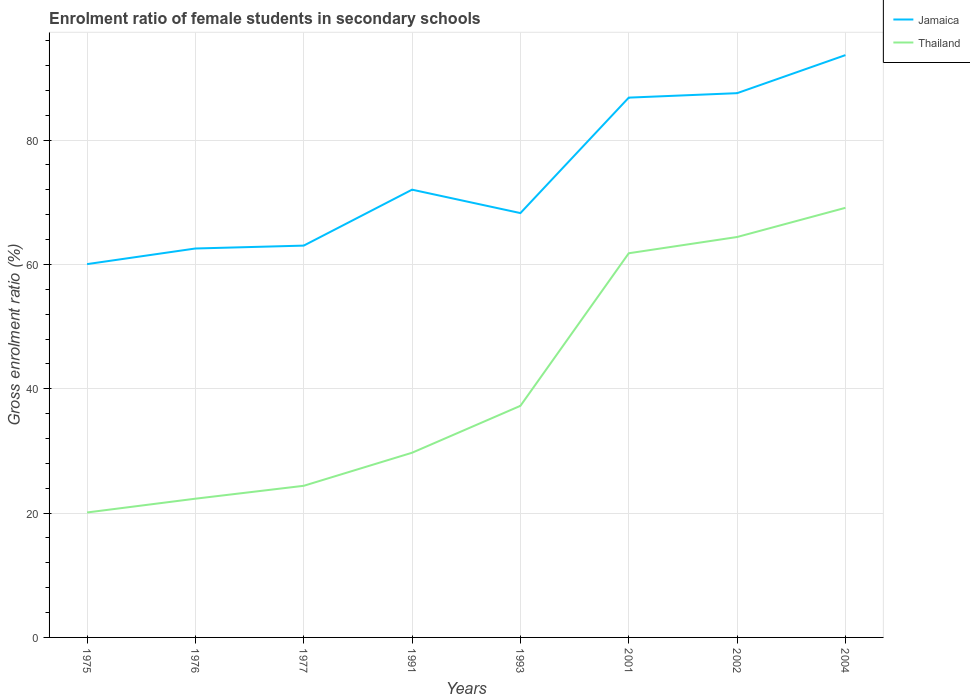How many different coloured lines are there?
Ensure brevity in your answer.  2. Does the line corresponding to Jamaica intersect with the line corresponding to Thailand?
Give a very brief answer. No. Across all years, what is the maximum enrolment ratio of female students in secondary schools in Thailand?
Offer a terse response. 20.1. In which year was the enrolment ratio of female students in secondary schools in Thailand maximum?
Keep it short and to the point. 1975. What is the total enrolment ratio of female students in secondary schools in Thailand in the graph?
Give a very brief answer. -44.71. What is the difference between the highest and the second highest enrolment ratio of female students in secondary schools in Jamaica?
Offer a terse response. 33.62. How many lines are there?
Make the answer very short. 2. How many years are there in the graph?
Offer a terse response. 8. What is the difference between two consecutive major ticks on the Y-axis?
Your answer should be very brief. 20. Does the graph contain any zero values?
Provide a short and direct response. No. Does the graph contain grids?
Give a very brief answer. Yes. How many legend labels are there?
Provide a succinct answer. 2. What is the title of the graph?
Offer a terse response. Enrolment ratio of female students in secondary schools. Does "Antigua and Barbuda" appear as one of the legend labels in the graph?
Ensure brevity in your answer.  No. What is the label or title of the X-axis?
Give a very brief answer. Years. What is the label or title of the Y-axis?
Your response must be concise. Gross enrolment ratio (%). What is the Gross enrolment ratio (%) in Jamaica in 1975?
Keep it short and to the point. 60.05. What is the Gross enrolment ratio (%) in Thailand in 1975?
Make the answer very short. 20.1. What is the Gross enrolment ratio (%) in Jamaica in 1976?
Make the answer very short. 62.56. What is the Gross enrolment ratio (%) in Thailand in 1976?
Keep it short and to the point. 22.32. What is the Gross enrolment ratio (%) in Jamaica in 1977?
Keep it short and to the point. 63.03. What is the Gross enrolment ratio (%) in Thailand in 1977?
Give a very brief answer. 24.39. What is the Gross enrolment ratio (%) in Jamaica in 1991?
Provide a succinct answer. 72.02. What is the Gross enrolment ratio (%) in Thailand in 1991?
Offer a very short reply. 29.71. What is the Gross enrolment ratio (%) of Jamaica in 1993?
Your response must be concise. 68.26. What is the Gross enrolment ratio (%) of Thailand in 1993?
Your response must be concise. 37.25. What is the Gross enrolment ratio (%) in Jamaica in 2001?
Your answer should be very brief. 86.83. What is the Gross enrolment ratio (%) of Thailand in 2001?
Keep it short and to the point. 61.8. What is the Gross enrolment ratio (%) of Jamaica in 2002?
Provide a succinct answer. 87.54. What is the Gross enrolment ratio (%) in Thailand in 2002?
Offer a terse response. 64.41. What is the Gross enrolment ratio (%) of Jamaica in 2004?
Ensure brevity in your answer.  93.67. What is the Gross enrolment ratio (%) of Thailand in 2004?
Your answer should be compact. 69.1. Across all years, what is the maximum Gross enrolment ratio (%) of Jamaica?
Provide a succinct answer. 93.67. Across all years, what is the maximum Gross enrolment ratio (%) in Thailand?
Your answer should be compact. 69.1. Across all years, what is the minimum Gross enrolment ratio (%) of Jamaica?
Your response must be concise. 60.05. Across all years, what is the minimum Gross enrolment ratio (%) in Thailand?
Your answer should be compact. 20.1. What is the total Gross enrolment ratio (%) of Jamaica in the graph?
Offer a very short reply. 593.95. What is the total Gross enrolment ratio (%) in Thailand in the graph?
Your response must be concise. 329.07. What is the difference between the Gross enrolment ratio (%) in Jamaica in 1975 and that in 1976?
Your answer should be very brief. -2.51. What is the difference between the Gross enrolment ratio (%) of Thailand in 1975 and that in 1976?
Offer a very short reply. -2.22. What is the difference between the Gross enrolment ratio (%) in Jamaica in 1975 and that in 1977?
Ensure brevity in your answer.  -2.98. What is the difference between the Gross enrolment ratio (%) of Thailand in 1975 and that in 1977?
Your answer should be compact. -4.29. What is the difference between the Gross enrolment ratio (%) in Jamaica in 1975 and that in 1991?
Provide a short and direct response. -11.98. What is the difference between the Gross enrolment ratio (%) of Thailand in 1975 and that in 1991?
Your answer should be compact. -9.61. What is the difference between the Gross enrolment ratio (%) of Jamaica in 1975 and that in 1993?
Keep it short and to the point. -8.21. What is the difference between the Gross enrolment ratio (%) in Thailand in 1975 and that in 1993?
Provide a short and direct response. -17.16. What is the difference between the Gross enrolment ratio (%) in Jamaica in 1975 and that in 2001?
Provide a short and direct response. -26.78. What is the difference between the Gross enrolment ratio (%) of Thailand in 1975 and that in 2001?
Provide a short and direct response. -41.7. What is the difference between the Gross enrolment ratio (%) in Jamaica in 1975 and that in 2002?
Offer a terse response. -27.5. What is the difference between the Gross enrolment ratio (%) of Thailand in 1975 and that in 2002?
Offer a very short reply. -44.31. What is the difference between the Gross enrolment ratio (%) of Jamaica in 1975 and that in 2004?
Offer a terse response. -33.62. What is the difference between the Gross enrolment ratio (%) of Thailand in 1975 and that in 2004?
Provide a short and direct response. -49.01. What is the difference between the Gross enrolment ratio (%) in Jamaica in 1976 and that in 1977?
Provide a short and direct response. -0.47. What is the difference between the Gross enrolment ratio (%) of Thailand in 1976 and that in 1977?
Make the answer very short. -2.07. What is the difference between the Gross enrolment ratio (%) in Jamaica in 1976 and that in 1991?
Make the answer very short. -9.46. What is the difference between the Gross enrolment ratio (%) of Thailand in 1976 and that in 1991?
Offer a very short reply. -7.39. What is the difference between the Gross enrolment ratio (%) in Jamaica in 1976 and that in 1993?
Give a very brief answer. -5.7. What is the difference between the Gross enrolment ratio (%) of Thailand in 1976 and that in 1993?
Provide a succinct answer. -14.94. What is the difference between the Gross enrolment ratio (%) of Jamaica in 1976 and that in 2001?
Your answer should be very brief. -24.27. What is the difference between the Gross enrolment ratio (%) in Thailand in 1976 and that in 2001?
Offer a terse response. -39.48. What is the difference between the Gross enrolment ratio (%) of Jamaica in 1976 and that in 2002?
Keep it short and to the point. -24.98. What is the difference between the Gross enrolment ratio (%) of Thailand in 1976 and that in 2002?
Give a very brief answer. -42.09. What is the difference between the Gross enrolment ratio (%) in Jamaica in 1976 and that in 2004?
Make the answer very short. -31.11. What is the difference between the Gross enrolment ratio (%) of Thailand in 1976 and that in 2004?
Your answer should be very brief. -46.79. What is the difference between the Gross enrolment ratio (%) of Jamaica in 1977 and that in 1991?
Provide a succinct answer. -9. What is the difference between the Gross enrolment ratio (%) of Thailand in 1977 and that in 1991?
Ensure brevity in your answer.  -5.32. What is the difference between the Gross enrolment ratio (%) of Jamaica in 1977 and that in 1993?
Make the answer very short. -5.23. What is the difference between the Gross enrolment ratio (%) in Thailand in 1977 and that in 1993?
Give a very brief answer. -12.86. What is the difference between the Gross enrolment ratio (%) of Jamaica in 1977 and that in 2001?
Your answer should be very brief. -23.8. What is the difference between the Gross enrolment ratio (%) of Thailand in 1977 and that in 2001?
Provide a short and direct response. -37.41. What is the difference between the Gross enrolment ratio (%) in Jamaica in 1977 and that in 2002?
Your response must be concise. -24.52. What is the difference between the Gross enrolment ratio (%) of Thailand in 1977 and that in 2002?
Ensure brevity in your answer.  -40.02. What is the difference between the Gross enrolment ratio (%) in Jamaica in 1977 and that in 2004?
Provide a succinct answer. -30.64. What is the difference between the Gross enrolment ratio (%) in Thailand in 1977 and that in 2004?
Keep it short and to the point. -44.71. What is the difference between the Gross enrolment ratio (%) in Jamaica in 1991 and that in 1993?
Provide a succinct answer. 3.77. What is the difference between the Gross enrolment ratio (%) in Thailand in 1991 and that in 1993?
Provide a short and direct response. -7.55. What is the difference between the Gross enrolment ratio (%) in Jamaica in 1991 and that in 2001?
Provide a short and direct response. -14.8. What is the difference between the Gross enrolment ratio (%) of Thailand in 1991 and that in 2001?
Ensure brevity in your answer.  -32.09. What is the difference between the Gross enrolment ratio (%) in Jamaica in 1991 and that in 2002?
Make the answer very short. -15.52. What is the difference between the Gross enrolment ratio (%) of Thailand in 1991 and that in 2002?
Your response must be concise. -34.7. What is the difference between the Gross enrolment ratio (%) in Jamaica in 1991 and that in 2004?
Your answer should be compact. -21.64. What is the difference between the Gross enrolment ratio (%) in Thailand in 1991 and that in 2004?
Provide a short and direct response. -39.4. What is the difference between the Gross enrolment ratio (%) in Jamaica in 1993 and that in 2001?
Offer a terse response. -18.57. What is the difference between the Gross enrolment ratio (%) of Thailand in 1993 and that in 2001?
Offer a very short reply. -24.54. What is the difference between the Gross enrolment ratio (%) in Jamaica in 1993 and that in 2002?
Your response must be concise. -19.29. What is the difference between the Gross enrolment ratio (%) in Thailand in 1993 and that in 2002?
Provide a short and direct response. -27.15. What is the difference between the Gross enrolment ratio (%) in Jamaica in 1993 and that in 2004?
Ensure brevity in your answer.  -25.41. What is the difference between the Gross enrolment ratio (%) of Thailand in 1993 and that in 2004?
Make the answer very short. -31.85. What is the difference between the Gross enrolment ratio (%) of Jamaica in 2001 and that in 2002?
Make the answer very short. -0.72. What is the difference between the Gross enrolment ratio (%) of Thailand in 2001 and that in 2002?
Provide a succinct answer. -2.61. What is the difference between the Gross enrolment ratio (%) in Jamaica in 2001 and that in 2004?
Provide a short and direct response. -6.84. What is the difference between the Gross enrolment ratio (%) in Thailand in 2001 and that in 2004?
Your answer should be compact. -7.31. What is the difference between the Gross enrolment ratio (%) of Jamaica in 2002 and that in 2004?
Your answer should be compact. -6.12. What is the difference between the Gross enrolment ratio (%) of Thailand in 2002 and that in 2004?
Your answer should be compact. -4.7. What is the difference between the Gross enrolment ratio (%) in Jamaica in 1975 and the Gross enrolment ratio (%) in Thailand in 1976?
Offer a terse response. 37.73. What is the difference between the Gross enrolment ratio (%) of Jamaica in 1975 and the Gross enrolment ratio (%) of Thailand in 1977?
Provide a succinct answer. 35.66. What is the difference between the Gross enrolment ratio (%) in Jamaica in 1975 and the Gross enrolment ratio (%) in Thailand in 1991?
Make the answer very short. 30.34. What is the difference between the Gross enrolment ratio (%) in Jamaica in 1975 and the Gross enrolment ratio (%) in Thailand in 1993?
Make the answer very short. 22.79. What is the difference between the Gross enrolment ratio (%) of Jamaica in 1975 and the Gross enrolment ratio (%) of Thailand in 2001?
Your response must be concise. -1.75. What is the difference between the Gross enrolment ratio (%) of Jamaica in 1975 and the Gross enrolment ratio (%) of Thailand in 2002?
Keep it short and to the point. -4.36. What is the difference between the Gross enrolment ratio (%) of Jamaica in 1975 and the Gross enrolment ratio (%) of Thailand in 2004?
Your answer should be compact. -9.06. What is the difference between the Gross enrolment ratio (%) of Jamaica in 1976 and the Gross enrolment ratio (%) of Thailand in 1977?
Offer a very short reply. 38.17. What is the difference between the Gross enrolment ratio (%) in Jamaica in 1976 and the Gross enrolment ratio (%) in Thailand in 1991?
Provide a short and direct response. 32.85. What is the difference between the Gross enrolment ratio (%) in Jamaica in 1976 and the Gross enrolment ratio (%) in Thailand in 1993?
Offer a terse response. 25.31. What is the difference between the Gross enrolment ratio (%) in Jamaica in 1976 and the Gross enrolment ratio (%) in Thailand in 2001?
Provide a succinct answer. 0.76. What is the difference between the Gross enrolment ratio (%) of Jamaica in 1976 and the Gross enrolment ratio (%) of Thailand in 2002?
Your answer should be very brief. -1.85. What is the difference between the Gross enrolment ratio (%) in Jamaica in 1976 and the Gross enrolment ratio (%) in Thailand in 2004?
Your answer should be compact. -6.54. What is the difference between the Gross enrolment ratio (%) in Jamaica in 1977 and the Gross enrolment ratio (%) in Thailand in 1991?
Your response must be concise. 33.32. What is the difference between the Gross enrolment ratio (%) in Jamaica in 1977 and the Gross enrolment ratio (%) in Thailand in 1993?
Offer a very short reply. 25.77. What is the difference between the Gross enrolment ratio (%) of Jamaica in 1977 and the Gross enrolment ratio (%) of Thailand in 2001?
Provide a short and direct response. 1.23. What is the difference between the Gross enrolment ratio (%) of Jamaica in 1977 and the Gross enrolment ratio (%) of Thailand in 2002?
Provide a short and direct response. -1.38. What is the difference between the Gross enrolment ratio (%) in Jamaica in 1977 and the Gross enrolment ratio (%) in Thailand in 2004?
Keep it short and to the point. -6.08. What is the difference between the Gross enrolment ratio (%) of Jamaica in 1991 and the Gross enrolment ratio (%) of Thailand in 1993?
Offer a terse response. 34.77. What is the difference between the Gross enrolment ratio (%) in Jamaica in 1991 and the Gross enrolment ratio (%) in Thailand in 2001?
Keep it short and to the point. 10.23. What is the difference between the Gross enrolment ratio (%) in Jamaica in 1991 and the Gross enrolment ratio (%) in Thailand in 2002?
Your answer should be compact. 7.61. What is the difference between the Gross enrolment ratio (%) in Jamaica in 1991 and the Gross enrolment ratio (%) in Thailand in 2004?
Make the answer very short. 2.92. What is the difference between the Gross enrolment ratio (%) of Jamaica in 1993 and the Gross enrolment ratio (%) of Thailand in 2001?
Offer a terse response. 6.46. What is the difference between the Gross enrolment ratio (%) of Jamaica in 1993 and the Gross enrolment ratio (%) of Thailand in 2002?
Offer a very short reply. 3.85. What is the difference between the Gross enrolment ratio (%) of Jamaica in 1993 and the Gross enrolment ratio (%) of Thailand in 2004?
Your answer should be very brief. -0.85. What is the difference between the Gross enrolment ratio (%) of Jamaica in 2001 and the Gross enrolment ratio (%) of Thailand in 2002?
Provide a short and direct response. 22.42. What is the difference between the Gross enrolment ratio (%) in Jamaica in 2001 and the Gross enrolment ratio (%) in Thailand in 2004?
Provide a succinct answer. 17.72. What is the difference between the Gross enrolment ratio (%) in Jamaica in 2002 and the Gross enrolment ratio (%) in Thailand in 2004?
Make the answer very short. 18.44. What is the average Gross enrolment ratio (%) in Jamaica per year?
Your response must be concise. 74.24. What is the average Gross enrolment ratio (%) in Thailand per year?
Your answer should be compact. 41.13. In the year 1975, what is the difference between the Gross enrolment ratio (%) of Jamaica and Gross enrolment ratio (%) of Thailand?
Provide a short and direct response. 39.95. In the year 1976, what is the difference between the Gross enrolment ratio (%) of Jamaica and Gross enrolment ratio (%) of Thailand?
Offer a very short reply. 40.24. In the year 1977, what is the difference between the Gross enrolment ratio (%) of Jamaica and Gross enrolment ratio (%) of Thailand?
Offer a very short reply. 38.64. In the year 1991, what is the difference between the Gross enrolment ratio (%) of Jamaica and Gross enrolment ratio (%) of Thailand?
Ensure brevity in your answer.  42.31. In the year 1993, what is the difference between the Gross enrolment ratio (%) in Jamaica and Gross enrolment ratio (%) in Thailand?
Keep it short and to the point. 31. In the year 2001, what is the difference between the Gross enrolment ratio (%) in Jamaica and Gross enrolment ratio (%) in Thailand?
Provide a short and direct response. 25.03. In the year 2002, what is the difference between the Gross enrolment ratio (%) in Jamaica and Gross enrolment ratio (%) in Thailand?
Provide a succinct answer. 23.14. In the year 2004, what is the difference between the Gross enrolment ratio (%) of Jamaica and Gross enrolment ratio (%) of Thailand?
Your answer should be compact. 24.56. What is the ratio of the Gross enrolment ratio (%) in Jamaica in 1975 to that in 1976?
Keep it short and to the point. 0.96. What is the ratio of the Gross enrolment ratio (%) of Thailand in 1975 to that in 1976?
Keep it short and to the point. 0.9. What is the ratio of the Gross enrolment ratio (%) of Jamaica in 1975 to that in 1977?
Keep it short and to the point. 0.95. What is the ratio of the Gross enrolment ratio (%) of Thailand in 1975 to that in 1977?
Offer a terse response. 0.82. What is the ratio of the Gross enrolment ratio (%) of Jamaica in 1975 to that in 1991?
Your answer should be compact. 0.83. What is the ratio of the Gross enrolment ratio (%) in Thailand in 1975 to that in 1991?
Your response must be concise. 0.68. What is the ratio of the Gross enrolment ratio (%) in Jamaica in 1975 to that in 1993?
Your response must be concise. 0.88. What is the ratio of the Gross enrolment ratio (%) of Thailand in 1975 to that in 1993?
Make the answer very short. 0.54. What is the ratio of the Gross enrolment ratio (%) of Jamaica in 1975 to that in 2001?
Offer a very short reply. 0.69. What is the ratio of the Gross enrolment ratio (%) in Thailand in 1975 to that in 2001?
Ensure brevity in your answer.  0.33. What is the ratio of the Gross enrolment ratio (%) in Jamaica in 1975 to that in 2002?
Your answer should be very brief. 0.69. What is the ratio of the Gross enrolment ratio (%) of Thailand in 1975 to that in 2002?
Keep it short and to the point. 0.31. What is the ratio of the Gross enrolment ratio (%) in Jamaica in 1975 to that in 2004?
Your answer should be very brief. 0.64. What is the ratio of the Gross enrolment ratio (%) of Thailand in 1975 to that in 2004?
Offer a very short reply. 0.29. What is the ratio of the Gross enrolment ratio (%) of Thailand in 1976 to that in 1977?
Make the answer very short. 0.91. What is the ratio of the Gross enrolment ratio (%) of Jamaica in 1976 to that in 1991?
Keep it short and to the point. 0.87. What is the ratio of the Gross enrolment ratio (%) in Thailand in 1976 to that in 1991?
Provide a short and direct response. 0.75. What is the ratio of the Gross enrolment ratio (%) of Jamaica in 1976 to that in 1993?
Your answer should be very brief. 0.92. What is the ratio of the Gross enrolment ratio (%) in Thailand in 1976 to that in 1993?
Ensure brevity in your answer.  0.6. What is the ratio of the Gross enrolment ratio (%) in Jamaica in 1976 to that in 2001?
Provide a short and direct response. 0.72. What is the ratio of the Gross enrolment ratio (%) in Thailand in 1976 to that in 2001?
Your response must be concise. 0.36. What is the ratio of the Gross enrolment ratio (%) of Jamaica in 1976 to that in 2002?
Provide a short and direct response. 0.71. What is the ratio of the Gross enrolment ratio (%) of Thailand in 1976 to that in 2002?
Offer a terse response. 0.35. What is the ratio of the Gross enrolment ratio (%) of Jamaica in 1976 to that in 2004?
Offer a terse response. 0.67. What is the ratio of the Gross enrolment ratio (%) in Thailand in 1976 to that in 2004?
Your answer should be compact. 0.32. What is the ratio of the Gross enrolment ratio (%) in Jamaica in 1977 to that in 1991?
Give a very brief answer. 0.88. What is the ratio of the Gross enrolment ratio (%) in Thailand in 1977 to that in 1991?
Make the answer very short. 0.82. What is the ratio of the Gross enrolment ratio (%) of Jamaica in 1977 to that in 1993?
Give a very brief answer. 0.92. What is the ratio of the Gross enrolment ratio (%) in Thailand in 1977 to that in 1993?
Make the answer very short. 0.65. What is the ratio of the Gross enrolment ratio (%) of Jamaica in 1977 to that in 2001?
Your response must be concise. 0.73. What is the ratio of the Gross enrolment ratio (%) in Thailand in 1977 to that in 2001?
Give a very brief answer. 0.39. What is the ratio of the Gross enrolment ratio (%) of Jamaica in 1977 to that in 2002?
Give a very brief answer. 0.72. What is the ratio of the Gross enrolment ratio (%) in Thailand in 1977 to that in 2002?
Provide a short and direct response. 0.38. What is the ratio of the Gross enrolment ratio (%) of Jamaica in 1977 to that in 2004?
Offer a terse response. 0.67. What is the ratio of the Gross enrolment ratio (%) of Thailand in 1977 to that in 2004?
Offer a very short reply. 0.35. What is the ratio of the Gross enrolment ratio (%) of Jamaica in 1991 to that in 1993?
Your response must be concise. 1.06. What is the ratio of the Gross enrolment ratio (%) in Thailand in 1991 to that in 1993?
Offer a terse response. 0.8. What is the ratio of the Gross enrolment ratio (%) in Jamaica in 1991 to that in 2001?
Your answer should be compact. 0.83. What is the ratio of the Gross enrolment ratio (%) of Thailand in 1991 to that in 2001?
Your answer should be very brief. 0.48. What is the ratio of the Gross enrolment ratio (%) in Jamaica in 1991 to that in 2002?
Keep it short and to the point. 0.82. What is the ratio of the Gross enrolment ratio (%) in Thailand in 1991 to that in 2002?
Provide a short and direct response. 0.46. What is the ratio of the Gross enrolment ratio (%) of Jamaica in 1991 to that in 2004?
Your answer should be very brief. 0.77. What is the ratio of the Gross enrolment ratio (%) of Thailand in 1991 to that in 2004?
Keep it short and to the point. 0.43. What is the ratio of the Gross enrolment ratio (%) of Jamaica in 1993 to that in 2001?
Your answer should be compact. 0.79. What is the ratio of the Gross enrolment ratio (%) in Thailand in 1993 to that in 2001?
Offer a very short reply. 0.6. What is the ratio of the Gross enrolment ratio (%) in Jamaica in 1993 to that in 2002?
Provide a short and direct response. 0.78. What is the ratio of the Gross enrolment ratio (%) of Thailand in 1993 to that in 2002?
Provide a short and direct response. 0.58. What is the ratio of the Gross enrolment ratio (%) in Jamaica in 1993 to that in 2004?
Offer a terse response. 0.73. What is the ratio of the Gross enrolment ratio (%) in Thailand in 1993 to that in 2004?
Provide a short and direct response. 0.54. What is the ratio of the Gross enrolment ratio (%) in Jamaica in 2001 to that in 2002?
Offer a very short reply. 0.99. What is the ratio of the Gross enrolment ratio (%) in Thailand in 2001 to that in 2002?
Your answer should be compact. 0.96. What is the ratio of the Gross enrolment ratio (%) of Jamaica in 2001 to that in 2004?
Keep it short and to the point. 0.93. What is the ratio of the Gross enrolment ratio (%) of Thailand in 2001 to that in 2004?
Your answer should be compact. 0.89. What is the ratio of the Gross enrolment ratio (%) in Jamaica in 2002 to that in 2004?
Your response must be concise. 0.93. What is the ratio of the Gross enrolment ratio (%) of Thailand in 2002 to that in 2004?
Keep it short and to the point. 0.93. What is the difference between the highest and the second highest Gross enrolment ratio (%) of Jamaica?
Your answer should be very brief. 6.12. What is the difference between the highest and the second highest Gross enrolment ratio (%) in Thailand?
Provide a short and direct response. 4.7. What is the difference between the highest and the lowest Gross enrolment ratio (%) of Jamaica?
Give a very brief answer. 33.62. What is the difference between the highest and the lowest Gross enrolment ratio (%) of Thailand?
Ensure brevity in your answer.  49.01. 